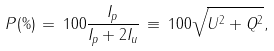<formula> <loc_0><loc_0><loc_500><loc_500>P ( \% ) \, = \, 1 0 0 \frac { I _ { p } } { I _ { p } + 2 I _ { u } } \, \equiv \, 1 0 0 \sqrt { U ^ { 2 } + Q ^ { 2 } } ,</formula> 